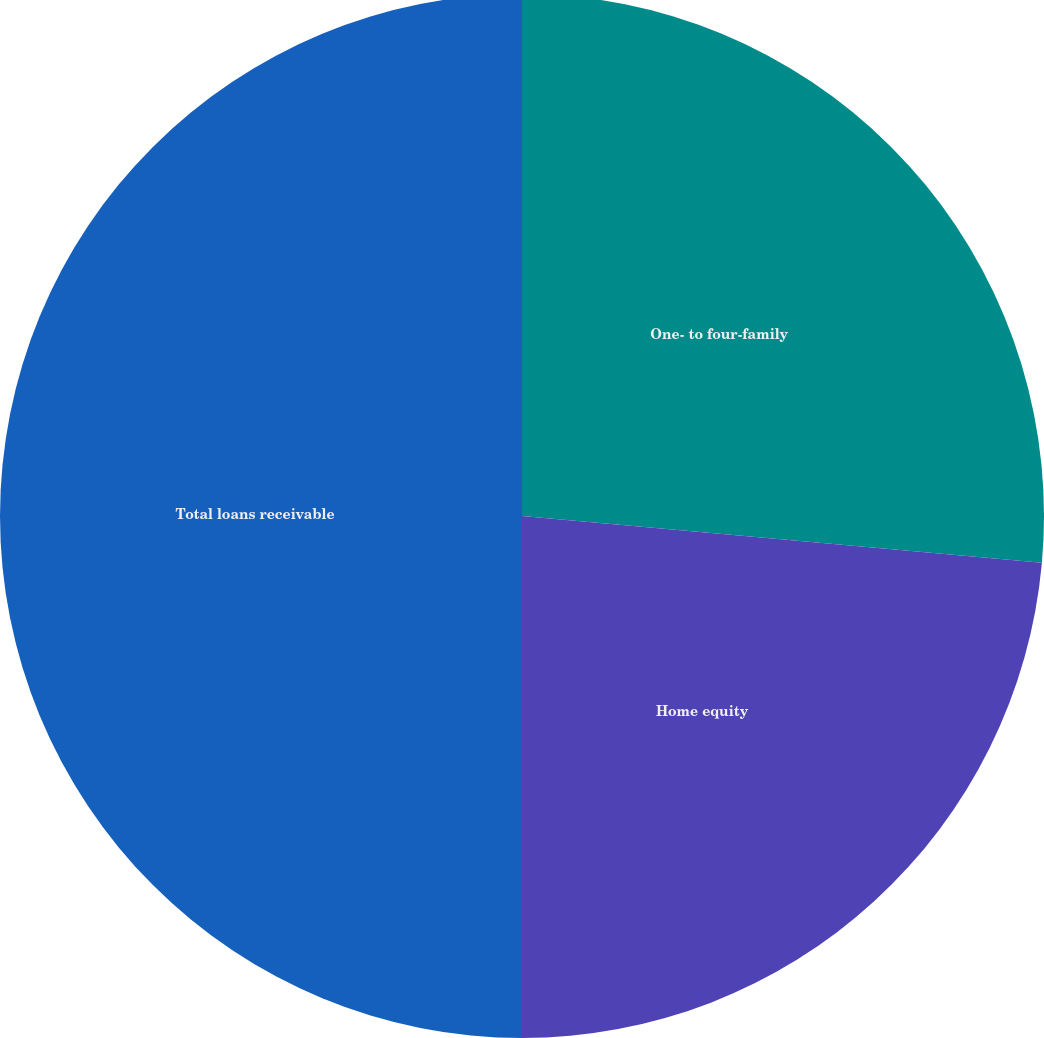<chart> <loc_0><loc_0><loc_500><loc_500><pie_chart><fcel>One- to four-family<fcel>Home equity<fcel>Total loans receivable<nl><fcel>26.43%<fcel>23.57%<fcel>50.0%<nl></chart> 